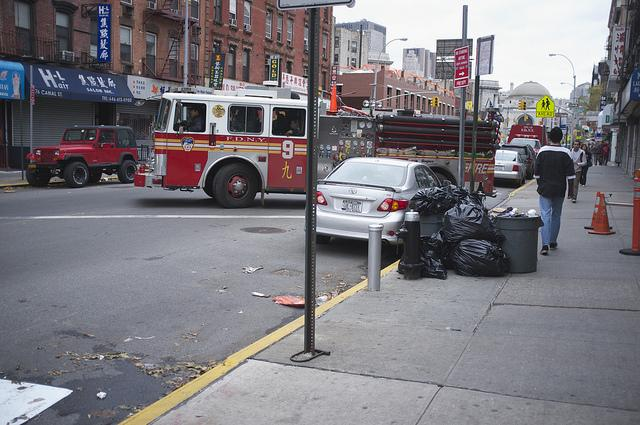For which city does this fire truck perform work?

Choices:
A) new york
B) kentucky
C) arkansas
D) new jersey new york 